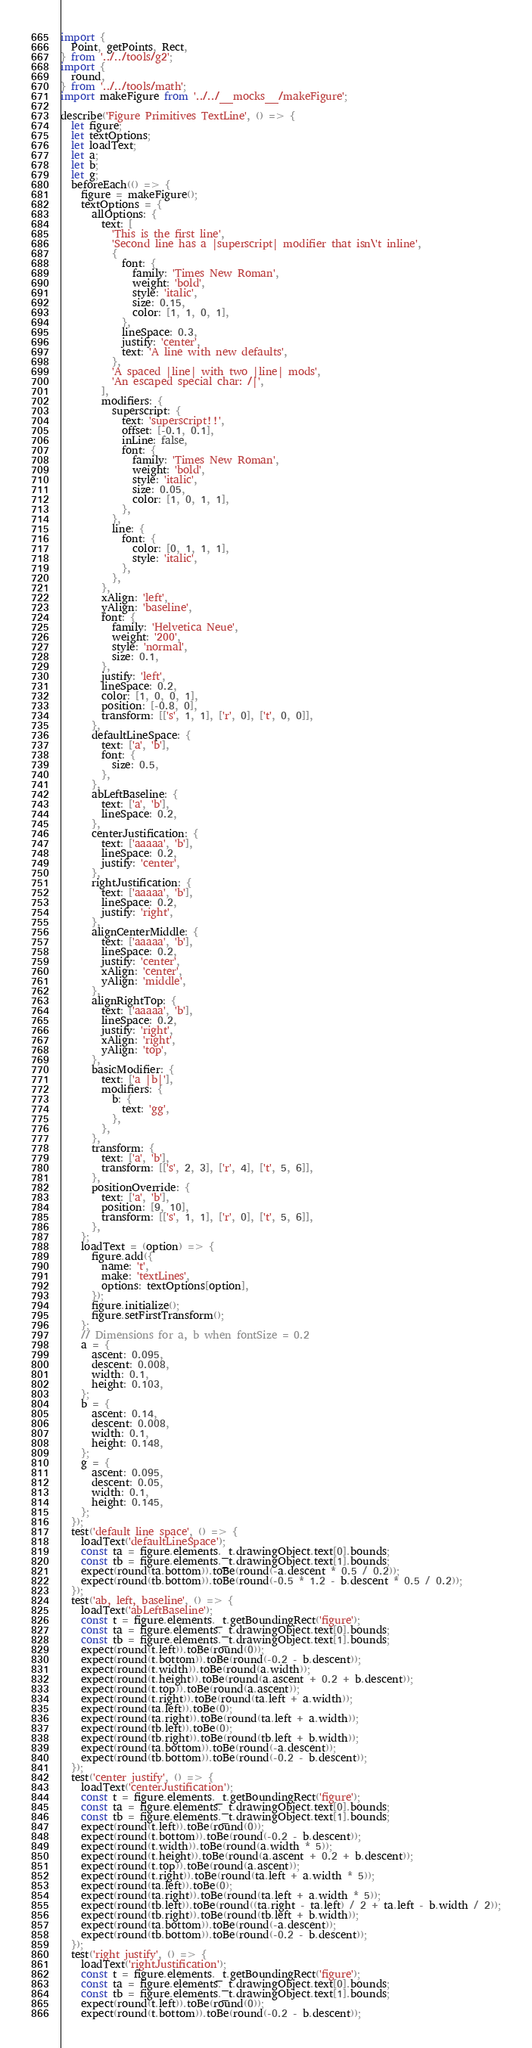<code> <loc_0><loc_0><loc_500><loc_500><_JavaScript_>import {
  Point, getPoints, Rect,
} from '../../tools/g2';
import {
  round,
} from '../../tools/math';
import makeFigure from '../../__mocks__/makeFigure';

describe('Figure Primitives TextLine', () => {
  let figure;
  let textOptions;
  let loadText;
  let a;
  let b;
  let g;
  beforeEach(() => {
    figure = makeFigure();
    textOptions = {
      allOptions: {
        text: [
          'This is the first line',
          'Second line has a |superscript| modifier that isn\'t inline',
          {
            font: {
              family: 'Times New Roman',
              weight: 'bold',
              style: 'italic',
              size: 0.15,
              color: [1, 1, 0, 1],
            },
            lineSpace: 0.3,
            justify: 'center',
            text: 'A line with new defaults',
          },
          'A spaced |line| with two |line| mods',
          'An escaped special char: /|',
        ],
        modifiers: {
          superscript: {
            text: 'superscript!!',
            offset: [-0.1, 0.1],
            inLine: false,
            font: {
              family: 'Times New Roman',
              weight: 'bold',
              style: 'italic',
              size: 0.05,
              color: [1, 0, 1, 1],
            },
          },
          line: {
            font: {
              color: [0, 1, 1, 1],
              style: 'italic',
            },
          },
        },
        xAlign: 'left',
        yAlign: 'baseline',
        font: {
          family: 'Helvetica Neue',
          weight: '200',
          style: 'normal',
          size: 0.1,
        },
        justify: 'left',
        lineSpace: 0.2,
        color: [1, 0, 0, 1],
        position: [-0.8, 0],
        transform: [['s', 1, 1], ['r', 0], ['t', 0, 0]],
      },
      defaultLineSpace: {
        text: ['a', 'b'],
        font: {
          size: 0.5,
        },
      },
      abLeftBaseline: {
        text: ['a', 'b'],
        lineSpace: 0.2,
      },
      centerJustification: {
        text: ['aaaaa', 'b'],
        lineSpace: 0.2,
        justify: 'center',
      },
      rightJustification: {
        text: ['aaaaa', 'b'],
        lineSpace: 0.2,
        justify: 'right',
      },
      alignCenterMiddle: {
        text: ['aaaaa', 'b'],
        lineSpace: 0.2,
        justify: 'center',
        xAlign: 'center',
        yAlign: 'middle',
      },
      alignRightTop: {
        text: ['aaaaa', 'b'],
        lineSpace: 0.2,
        justify: 'right',
        xAlign: 'right',
        yAlign: 'top',
      },
      basicModifier: {
        text: ['a |b|'],
        modifiers: {
          b: {
            text: 'gg',
          },
        },
      },
      transform: {
        text: ['a', 'b'],
        transform: [['s', 2, 3], ['r', 4], ['t', 5, 6]],
      },
      positionOverride: {
        text: ['a', 'b'],
        position: [9, 10],
        transform: [['s', 1, 1], ['r', 0], ['t', 5, 6]],
      },
    };
    loadText = (option) => {
      figure.add({
        name: 't',
        make: 'textLines',
        options: textOptions[option],
      });
      figure.initialize();
      figure.setFirstTransform();
    };
    // Dimensions for a, b when fontSize = 0.2
    a = {
      ascent: 0.095,
      descent: 0.008,
      width: 0.1,
      height: 0.103,
    };
    b = {
      ascent: 0.14,
      descent: 0.008,
      width: 0.1,
      height: 0.148,
    };
    g = {
      ascent: 0.095,
      descent: 0.05,
      width: 0.1,
      height: 0.145,
    };
  });
  test('default line space', () => {
    loadText('defaultLineSpace');
    const ta = figure.elements._t.drawingObject.text[0].bounds;
    const tb = figure.elements._t.drawingObject.text[1].bounds;
    expect(round(ta.bottom)).toBe(round(-a.descent * 0.5 / 0.2));
    expect(round(tb.bottom)).toBe(round(-0.5 * 1.2 - b.descent * 0.5 / 0.2));
  });
  test('ab, left, baseline', () => {
    loadText('abLeftBaseline');
    const t = figure.elements._t.getBoundingRect('figure');
    const ta = figure.elements._t.drawingObject.text[0].bounds;
    const tb = figure.elements._t.drawingObject.text[1].bounds;
    expect(round(t.left)).toBe(round(0));
    expect(round(t.bottom)).toBe(round(-0.2 - b.descent));
    expect(round(t.width)).toBe(round(a.width));
    expect(round(t.height)).toBe(round(a.ascent + 0.2 + b.descent));
    expect(round(t.top)).toBe(round(a.ascent));
    expect(round(t.right)).toBe(round(ta.left + a.width));
    expect(round(ta.left)).toBe(0);
    expect(round(ta.right)).toBe(round(ta.left + a.width));
    expect(round(tb.left)).toBe(0);
    expect(round(tb.right)).toBe(round(tb.left + b.width));
    expect(round(ta.bottom)).toBe(round(-a.descent));
    expect(round(tb.bottom)).toBe(round(-0.2 - b.descent));
  });
  test('center justify', () => {
    loadText('centerJustification');
    const t = figure.elements._t.getBoundingRect('figure');
    const ta = figure.elements._t.drawingObject.text[0].bounds;
    const tb = figure.elements._t.drawingObject.text[1].bounds;
    expect(round(t.left)).toBe(round(0));
    expect(round(t.bottom)).toBe(round(-0.2 - b.descent));
    expect(round(t.width)).toBe(round(a.width * 5));
    expect(round(t.height)).toBe(round(a.ascent + 0.2 + b.descent));
    expect(round(t.top)).toBe(round(a.ascent));
    expect(round(t.right)).toBe(round(ta.left + a.width * 5));
    expect(round(ta.left)).toBe(0);
    expect(round(ta.right)).toBe(round(ta.left + a.width * 5));
    expect(round(tb.left)).toBe(round((ta.right - ta.left) / 2 + ta.left - b.width / 2));
    expect(round(tb.right)).toBe(round(tb.left + b.width));
    expect(round(ta.bottom)).toBe(round(-a.descent));
    expect(round(tb.bottom)).toBe(round(-0.2 - b.descent));
  });
  test('right justify', () => {
    loadText('rightJustification');
    const t = figure.elements._t.getBoundingRect('figure');
    const ta = figure.elements._t.drawingObject.text[0].bounds;
    const tb = figure.elements._t.drawingObject.text[1].bounds;
    expect(round(t.left)).toBe(round(0));
    expect(round(t.bottom)).toBe(round(-0.2 - b.descent));</code> 